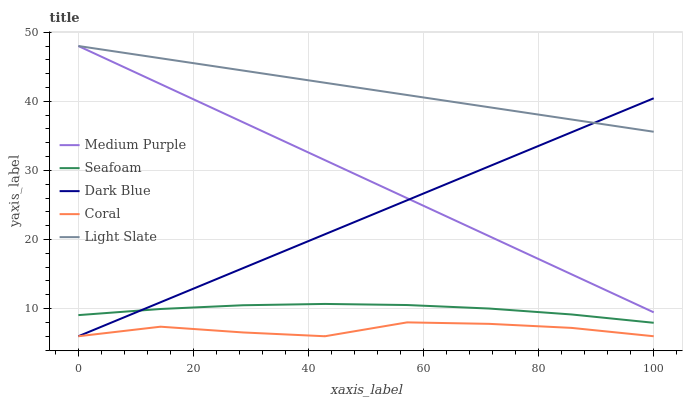Does Dark Blue have the minimum area under the curve?
Answer yes or no. No. Does Dark Blue have the maximum area under the curve?
Answer yes or no. No. Is Coral the smoothest?
Answer yes or no. No. Is Dark Blue the roughest?
Answer yes or no. No. Does Seafoam have the lowest value?
Answer yes or no. No. Does Dark Blue have the highest value?
Answer yes or no. No. Is Coral less than Seafoam?
Answer yes or no. Yes. Is Seafoam greater than Coral?
Answer yes or no. Yes. Does Coral intersect Seafoam?
Answer yes or no. No. 